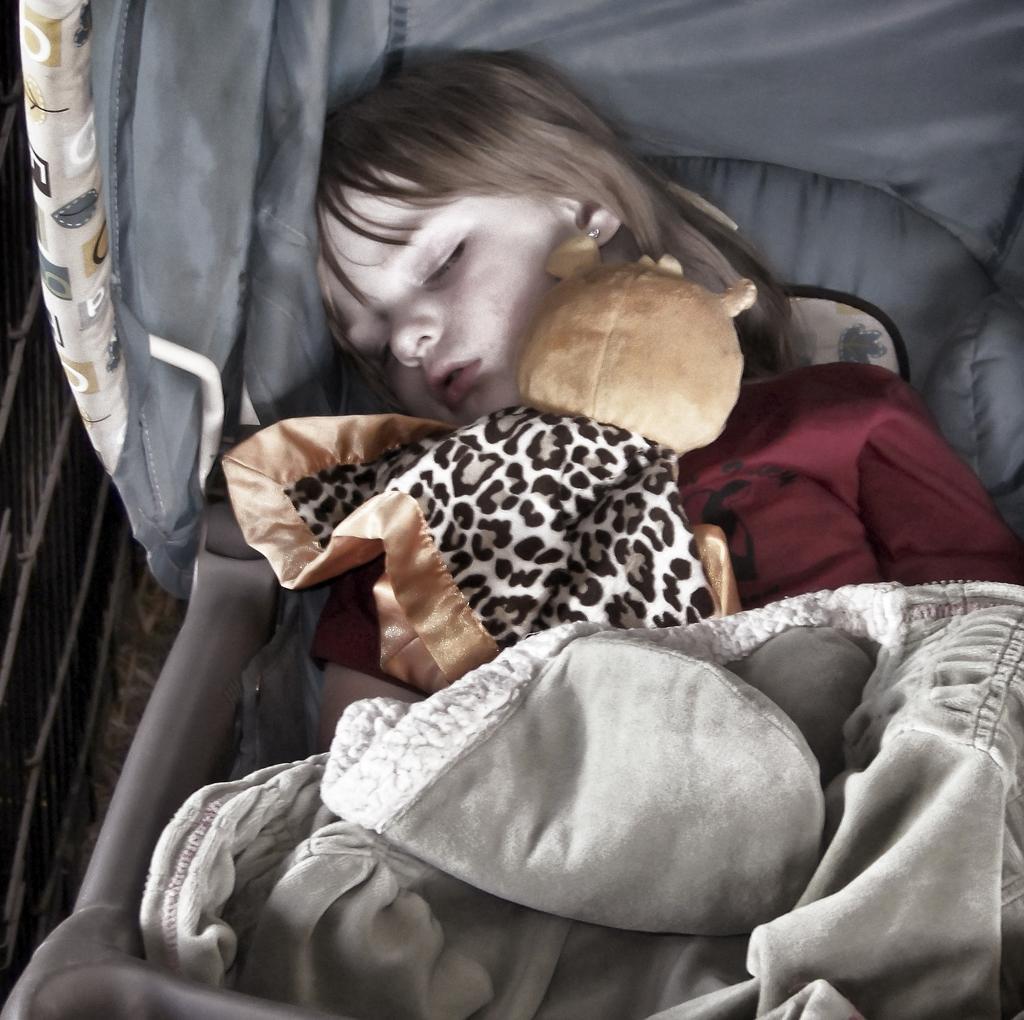How would you summarize this image in a sentence or two? In this image we can see one girl sleeping on the surface which looks like a chair, one doll and blanket on the girl. There is one object looks like a fence on the left side of the image, one object looks like a carpet on the floor. 